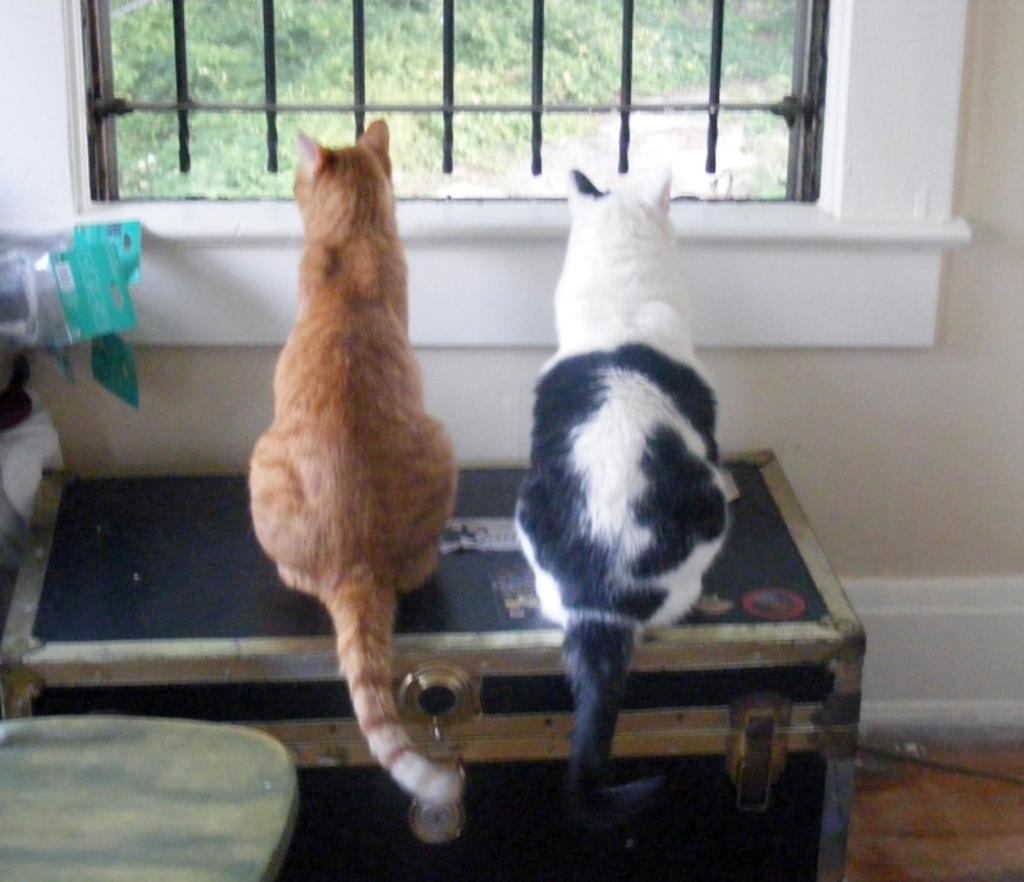How many animals are present in the image? There are two animals in the image. What are the animals doing in the image? The animals are sitting on a box and looking out of a window. What can be seen outside the window? There are plants visible behind the window. Where is the stove located in the image? There is no stove present in the image. What type of nest can be seen in the image? There is no nest present in the image. 